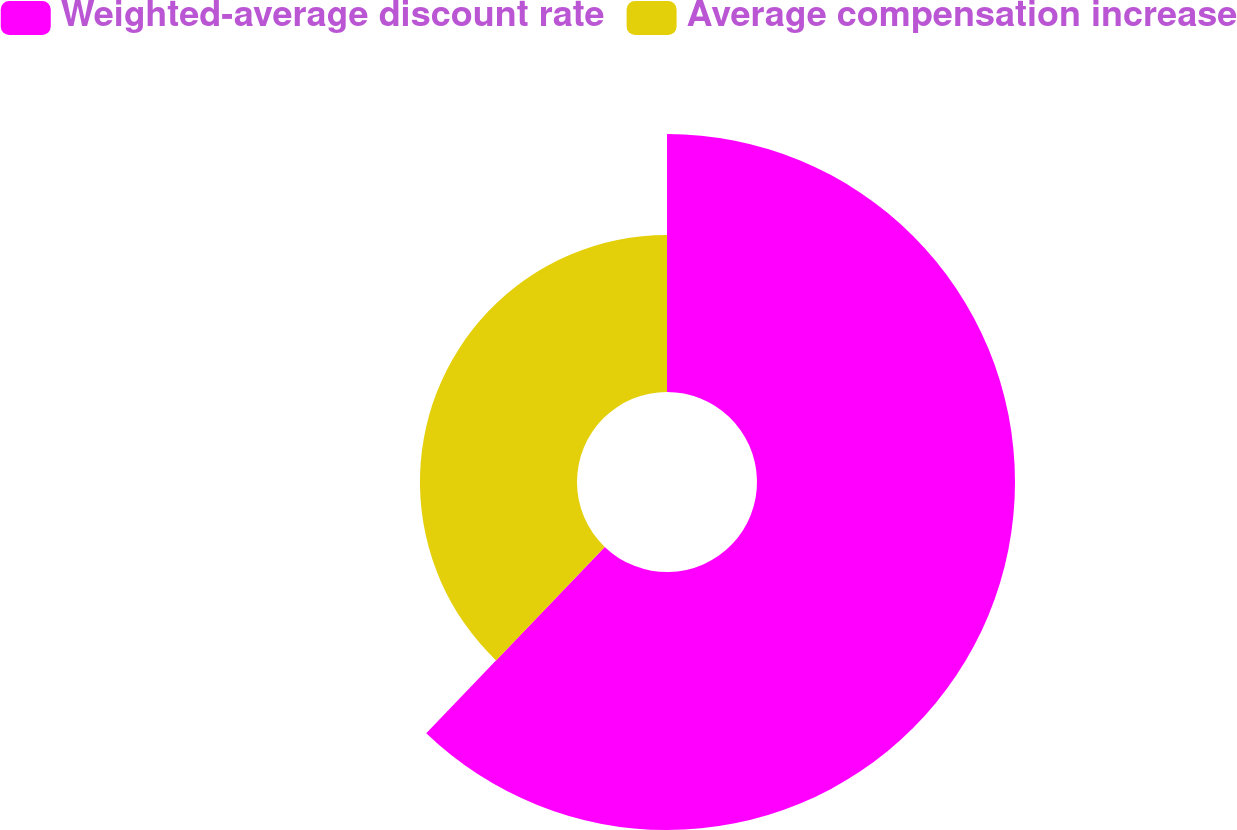<chart> <loc_0><loc_0><loc_500><loc_500><pie_chart><fcel>Weighted-average discount rate<fcel>Average compensation increase<nl><fcel>62.16%<fcel>37.84%<nl></chart> 